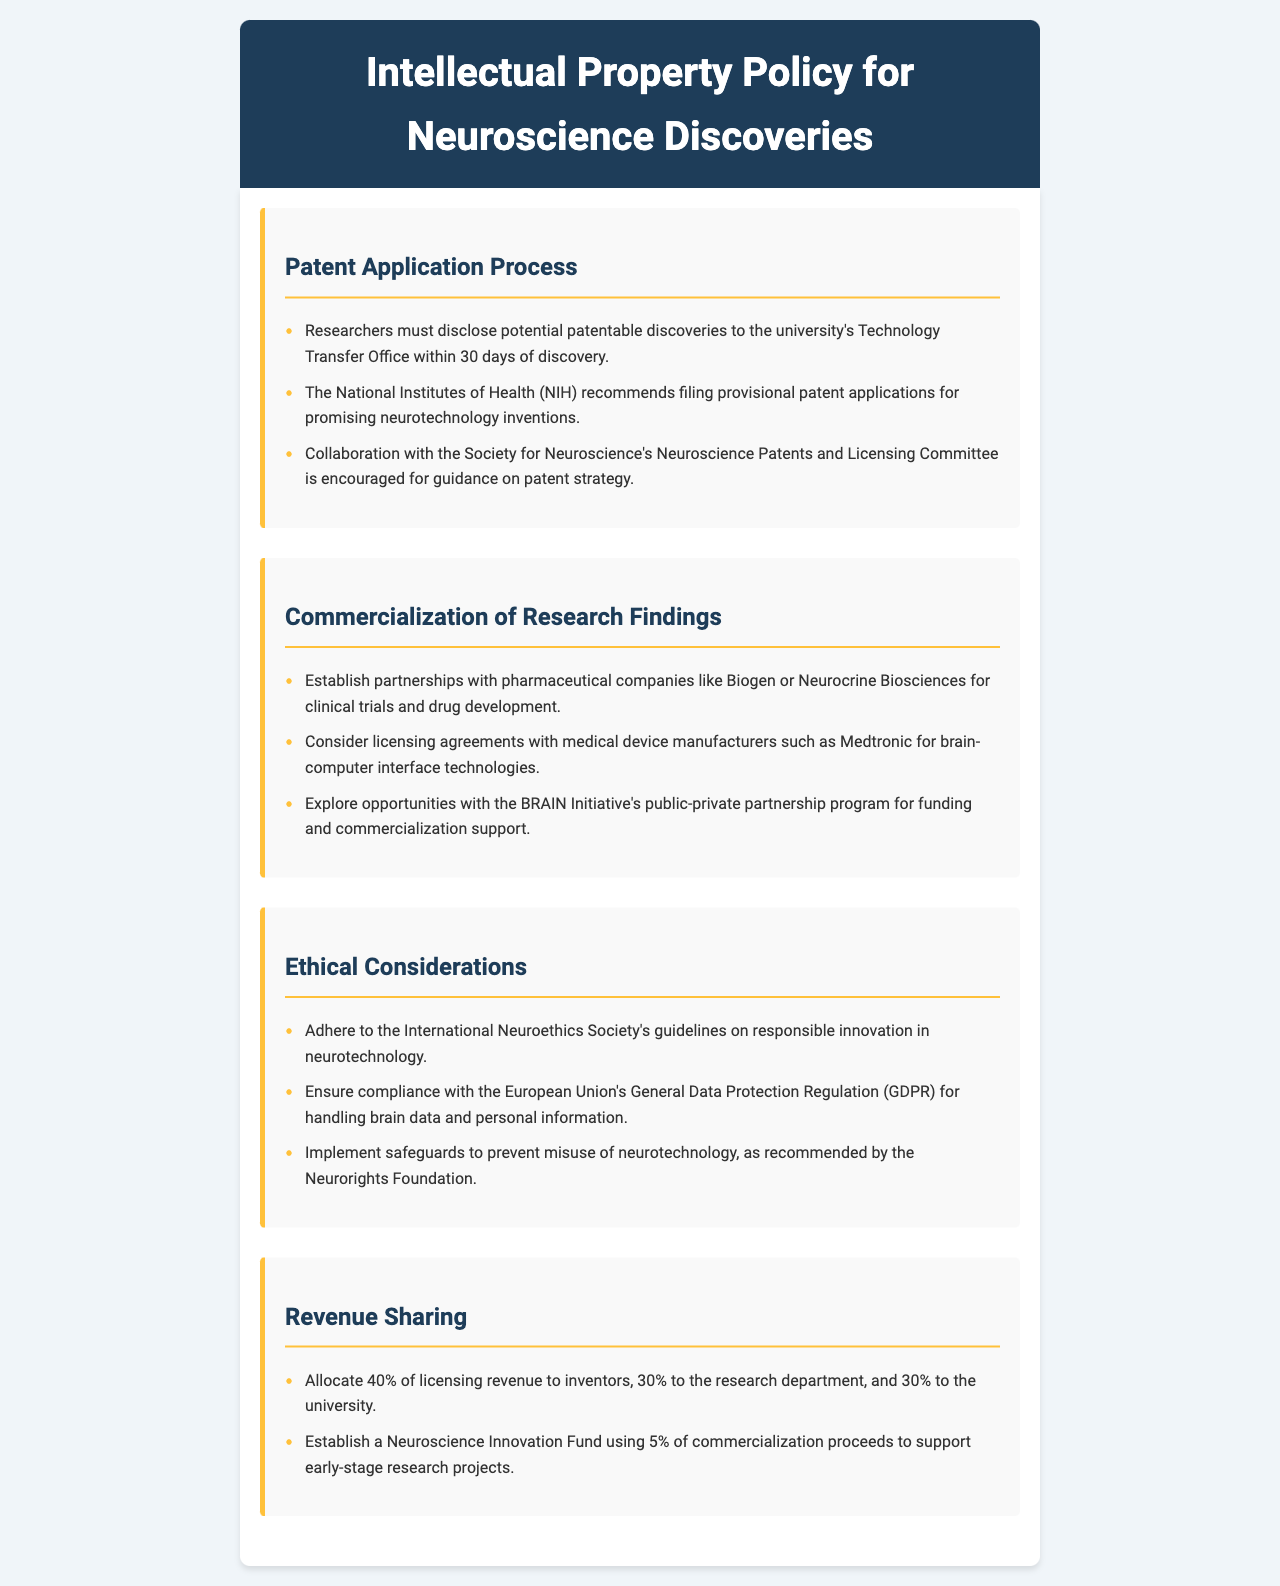What is the time frame for disclosing discoveries? Researchers must disclose potential patentable discoveries to the university's Technology Transfer Office within 30 days of discovery.
Answer: 30 days Which organization recommends provisional patent applications? The National Institutes of Health (NIH) recommends filing provisional patent applications for promising neurotechnology inventions.
Answer: National Institutes of Health (NIH) What percentage of licensing revenue is allocated to inventors? Allocate 40% of licensing revenue to inventors, 30% to the research department, and 30% to the university.
Answer: 40% What is encouraged for guidance on patent strategy? Collaboration with the Society for Neuroscience's Neuroscience Patents and Licensing Committee is encouraged for guidance on patent strategy.
Answer: Society for Neuroscience's Neuroscience Patents and Licensing Committee Which companies are suggested for partnerships in commercialization? Establish partnerships with pharmaceutical companies like Biogen or Neurocrine Biosciences for clinical trials and drug development.
Answer: Biogen or Neurocrine Biosciences 